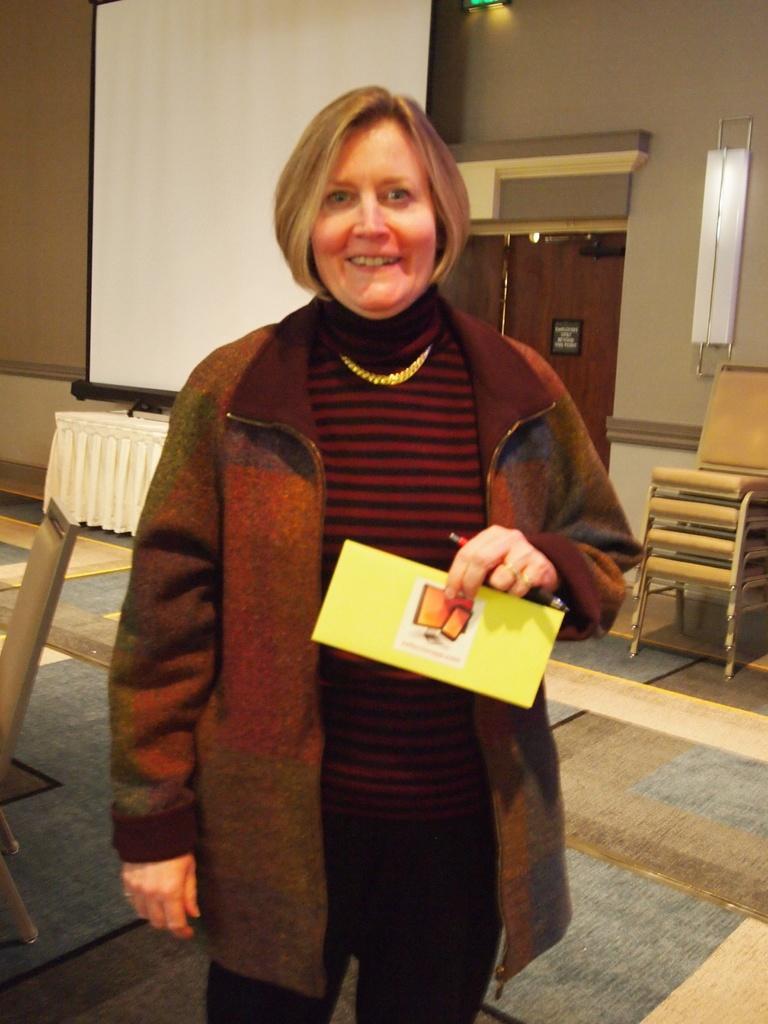Describe this image in one or two sentences. As we can see in the image there is a wall, chairs, screen and a woman standing over here. 